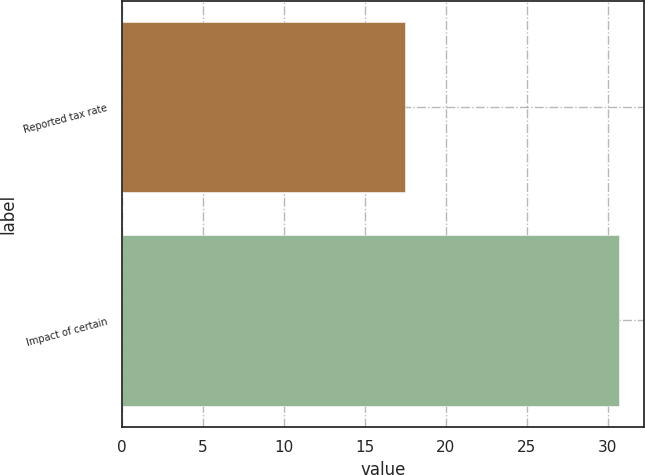Convert chart. <chart><loc_0><loc_0><loc_500><loc_500><bar_chart><fcel>Reported tax rate<fcel>Impact of certain<nl><fcel>17.5<fcel>30.7<nl></chart> 